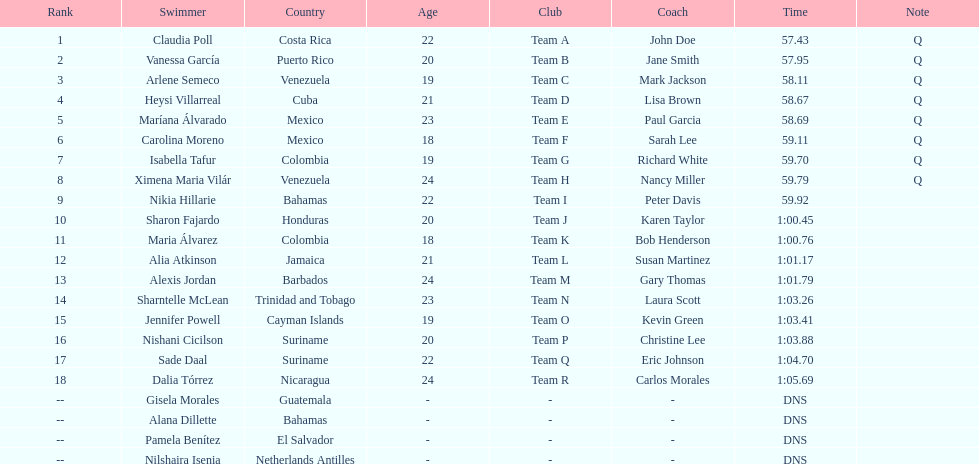I'm looking to parse the entire table for insights. Could you assist me with that? {'header': ['Rank', 'Swimmer', 'Country', 'Age', 'Club', 'Coach', 'Time', 'Note'], 'rows': [['1', 'Claudia Poll', 'Costa Rica', '22', 'Team A', 'John Doe', '57.43', 'Q'], ['2', 'Vanessa García', 'Puerto Rico', '20', 'Team B', 'Jane Smith', '57.95', 'Q'], ['3', 'Arlene Semeco', 'Venezuela', '19', 'Team C', 'Mark Jackson', '58.11', 'Q'], ['4', 'Heysi Villarreal', 'Cuba', '21', 'Team D', 'Lisa Brown', '58.67', 'Q'], ['5', 'Maríana Álvarado', 'Mexico', '23', 'Team E', 'Paul Garcia', '58.69', 'Q'], ['6', 'Carolina Moreno', 'Mexico', '18', 'Team F', 'Sarah Lee', '59.11', 'Q'], ['7', 'Isabella Tafur', 'Colombia', '19', 'Team G', 'Richard White', '59.70', 'Q'], ['8', 'Ximena Maria Vilár', 'Venezuela', '24', 'Team H', 'Nancy Miller', '59.79', 'Q'], ['9', 'Nikia Hillarie', 'Bahamas', '22', 'Team I', 'Peter Davis', '59.92', ''], ['10', 'Sharon Fajardo', 'Honduras', '20', 'Team J', 'Karen Taylor', '1:00.45', ''], ['11', 'Maria Álvarez', 'Colombia', '18', 'Team K', 'Bob Henderson', '1:00.76', ''], ['12', 'Alia Atkinson', 'Jamaica', '21', 'Team L', 'Susan Martinez', '1:01.17', ''], ['13', 'Alexis Jordan', 'Barbados', '24', 'Team M', 'Gary Thomas', '1:01.79', ''], ['14', 'Sharntelle McLean', 'Trinidad and Tobago', '23', 'Team N', 'Laura Scott', '1:03.26', ''], ['15', 'Jennifer Powell', 'Cayman Islands', '19', 'Team O', 'Kevin Green', '1:03.41', ''], ['16', 'Nishani Cicilson', 'Suriname', '20', 'Team P', 'Christine Lee', '1:03.88', ''], ['17', 'Sade Daal', 'Suriname', '22', 'Team Q', 'Eric Johnson', '1:04.70', ''], ['18', 'Dalia Tórrez', 'Nicaragua', '24', 'Team R', 'Carlos Morales', '1:05.69', ''], ['--', 'Gisela Morales', 'Guatemala', '-', '-', '-', 'DNS', ''], ['--', 'Alana Dillette', 'Bahamas', '-', '-', '-', 'DNS', ''], ['--', 'Pamela Benítez', 'El Salvador', '-', '-', '-', 'DNS', ''], ['--', 'Nilshaira Isenia', 'Netherlands Antilles', '-', '-', '-', 'DNS', '']]} Who finished after claudia poll? Vanessa García. 